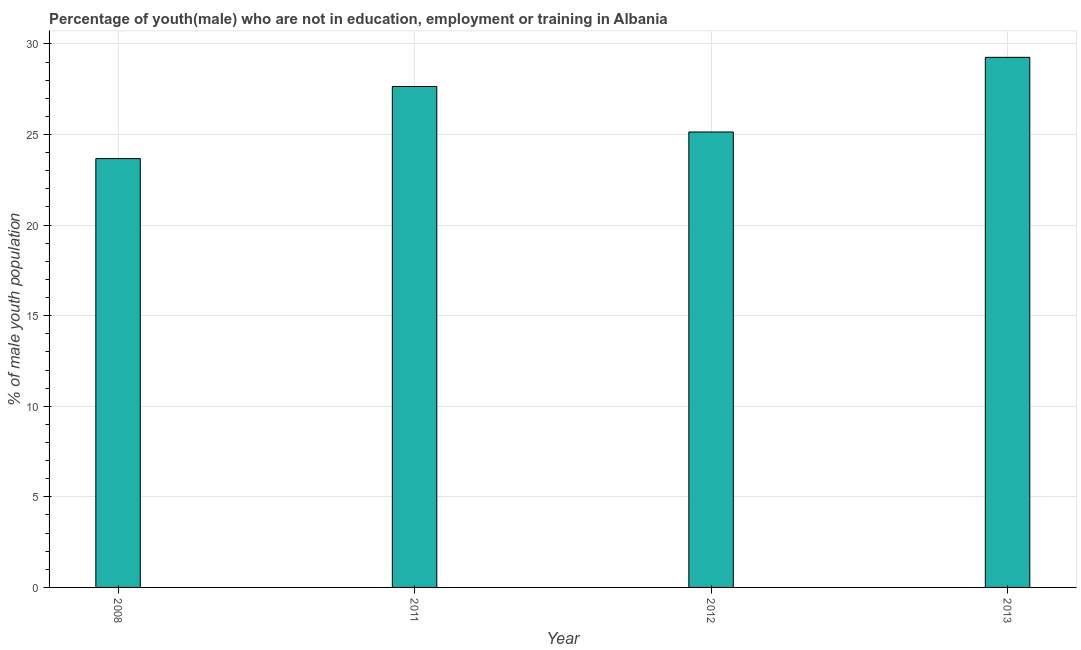What is the title of the graph?
Keep it short and to the point. Percentage of youth(male) who are not in education, employment or training in Albania. What is the label or title of the X-axis?
Provide a short and direct response. Year. What is the label or title of the Y-axis?
Your answer should be very brief. % of male youth population. What is the unemployed male youth population in 2008?
Keep it short and to the point. 23.67. Across all years, what is the maximum unemployed male youth population?
Your answer should be compact. 29.26. Across all years, what is the minimum unemployed male youth population?
Give a very brief answer. 23.67. In which year was the unemployed male youth population maximum?
Give a very brief answer. 2013. What is the sum of the unemployed male youth population?
Your answer should be compact. 105.72. What is the difference between the unemployed male youth population in 2012 and 2013?
Offer a very short reply. -4.12. What is the average unemployed male youth population per year?
Offer a terse response. 26.43. What is the median unemployed male youth population?
Your answer should be very brief. 26.39. In how many years, is the unemployed male youth population greater than 21 %?
Your answer should be very brief. 4. What is the ratio of the unemployed male youth population in 2008 to that in 2012?
Make the answer very short. 0.94. Is the difference between the unemployed male youth population in 2008 and 2011 greater than the difference between any two years?
Offer a terse response. No. What is the difference between the highest and the second highest unemployed male youth population?
Offer a very short reply. 1.61. Is the sum of the unemployed male youth population in 2012 and 2013 greater than the maximum unemployed male youth population across all years?
Your answer should be very brief. Yes. What is the difference between the highest and the lowest unemployed male youth population?
Keep it short and to the point. 5.59. In how many years, is the unemployed male youth population greater than the average unemployed male youth population taken over all years?
Ensure brevity in your answer.  2. How many bars are there?
Offer a terse response. 4. How many years are there in the graph?
Ensure brevity in your answer.  4. Are the values on the major ticks of Y-axis written in scientific E-notation?
Offer a terse response. No. What is the % of male youth population of 2008?
Make the answer very short. 23.67. What is the % of male youth population in 2011?
Ensure brevity in your answer.  27.65. What is the % of male youth population in 2012?
Ensure brevity in your answer.  25.14. What is the % of male youth population in 2013?
Provide a succinct answer. 29.26. What is the difference between the % of male youth population in 2008 and 2011?
Provide a succinct answer. -3.98. What is the difference between the % of male youth population in 2008 and 2012?
Your answer should be compact. -1.47. What is the difference between the % of male youth population in 2008 and 2013?
Make the answer very short. -5.59. What is the difference between the % of male youth population in 2011 and 2012?
Your response must be concise. 2.51. What is the difference between the % of male youth population in 2011 and 2013?
Your response must be concise. -1.61. What is the difference between the % of male youth population in 2012 and 2013?
Offer a very short reply. -4.12. What is the ratio of the % of male youth population in 2008 to that in 2011?
Offer a very short reply. 0.86. What is the ratio of the % of male youth population in 2008 to that in 2012?
Provide a short and direct response. 0.94. What is the ratio of the % of male youth population in 2008 to that in 2013?
Offer a very short reply. 0.81. What is the ratio of the % of male youth population in 2011 to that in 2013?
Offer a very short reply. 0.94. What is the ratio of the % of male youth population in 2012 to that in 2013?
Give a very brief answer. 0.86. 